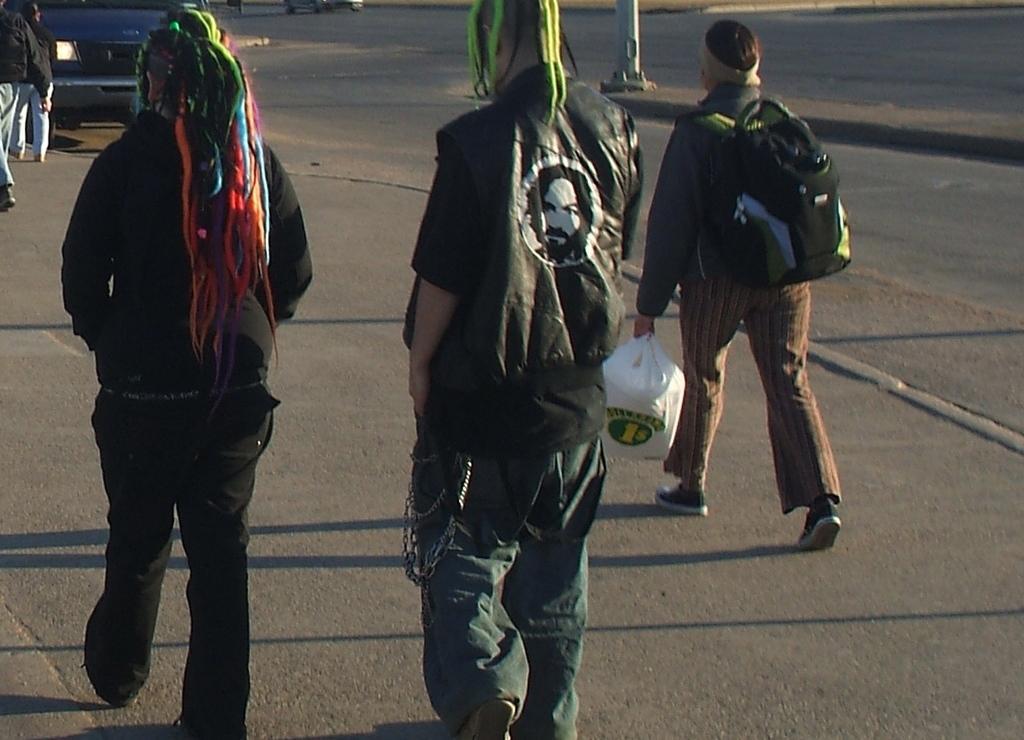Please provide a concise description of this image. In this image there are people walking on the road. In front of them there is a vehicle. In the center of the image there is a pole. 